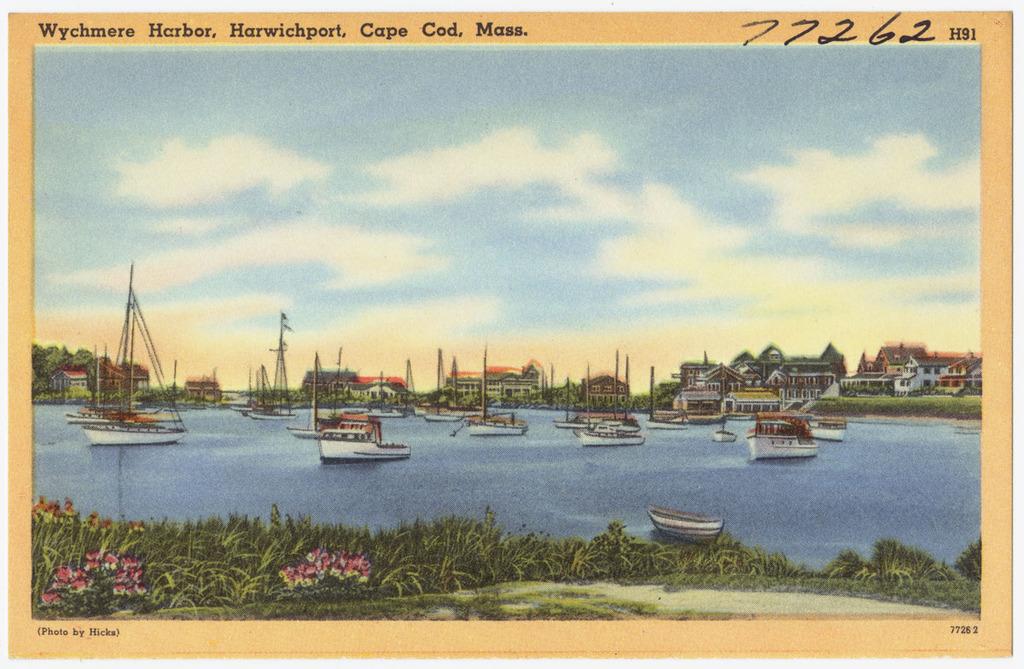Where is this a painting of?
Your answer should be compact. Wychmere harbor. 